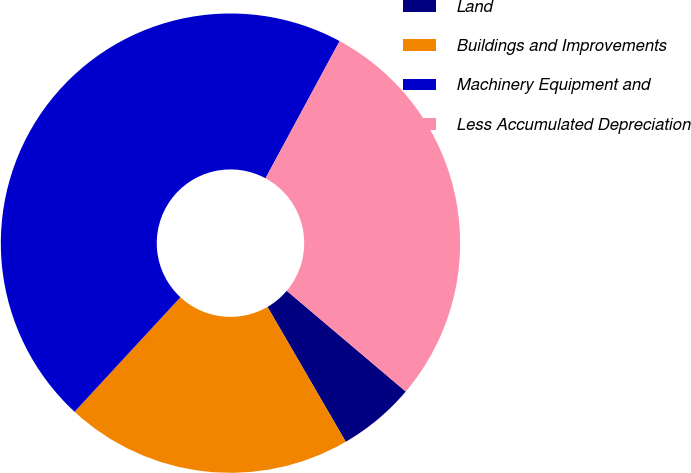Convert chart to OTSL. <chart><loc_0><loc_0><loc_500><loc_500><pie_chart><fcel>Land<fcel>Buildings and Improvements<fcel>Machinery Equipment and<fcel>Less Accumulated Depreciation<nl><fcel>5.45%<fcel>20.25%<fcel>46.01%<fcel>28.3%<nl></chart> 